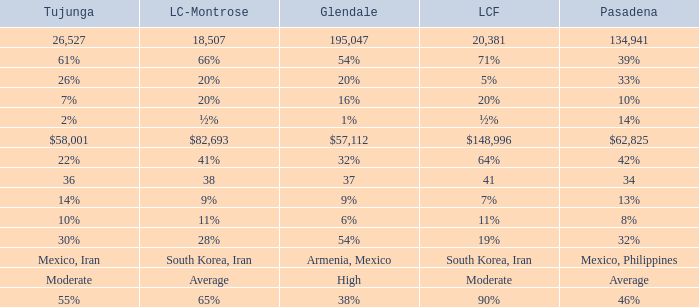What is the percentage of La Canada Flintridge when Tujunga is 7%? 20%. 